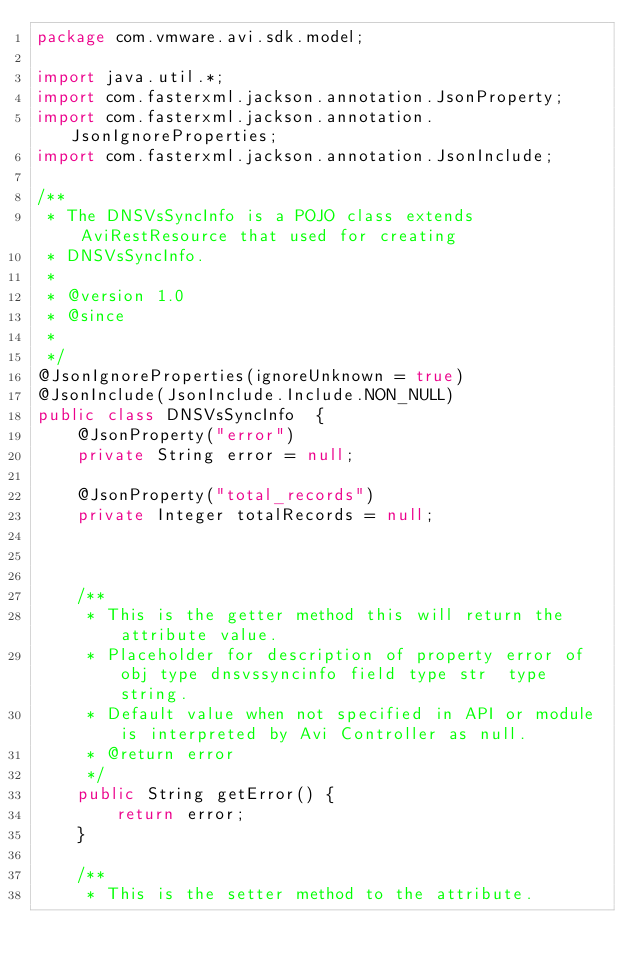<code> <loc_0><loc_0><loc_500><loc_500><_Java_>package com.vmware.avi.sdk.model;

import java.util.*;
import com.fasterxml.jackson.annotation.JsonProperty;
import com.fasterxml.jackson.annotation.JsonIgnoreProperties;
import com.fasterxml.jackson.annotation.JsonInclude;

/**
 * The DNSVsSyncInfo is a POJO class extends AviRestResource that used for creating
 * DNSVsSyncInfo.
 *
 * @version 1.0
 * @since 
 *
 */
@JsonIgnoreProperties(ignoreUnknown = true)
@JsonInclude(JsonInclude.Include.NON_NULL)
public class DNSVsSyncInfo  {
    @JsonProperty("error")
    private String error = null;

    @JsonProperty("total_records")
    private Integer totalRecords = null;



    /**
     * This is the getter method this will return the attribute value.
     * Placeholder for description of property error of obj type dnsvssyncinfo field type str  type string.
     * Default value when not specified in API or module is interpreted by Avi Controller as null.
     * @return error
     */
    public String getError() {
        return error;
    }

    /**
     * This is the setter method to the attribute.</code> 